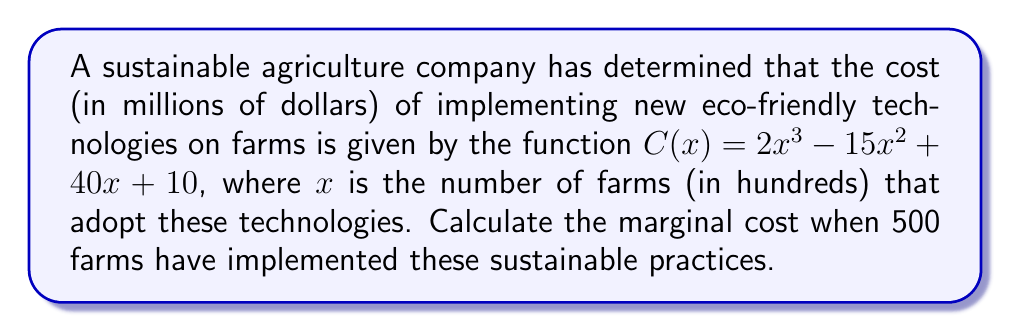Can you solve this math problem? To solve this problem, we need to follow these steps:

1) The marginal cost is given by the derivative of the cost function $C(x)$.

2) Let's find the derivative $C'(x)$:
   $$C'(x) = \frac{d}{dx}(2x^3 - 15x^2 + 40x + 10)$$
   $$C'(x) = 6x^2 - 30x + 40$$

3) We're asked to find the marginal cost when 500 farms have implemented the technologies. In the function, $x$ is in hundreds of farms, so 500 farms is represented by $x = 5$.

4) Now, let's substitute $x = 5$ into our derivative function:
   $$C'(5) = 6(5)^2 - 30(5) + 40$$
   $$C'(5) = 6(25) - 150 + 40$$
   $$C'(5) = 150 - 150 + 40$$
   $$C'(5) = 40$$

5) Therefore, the marginal cost when 500 farms have implemented the sustainable practices is 40 million dollars.
Answer: $40$ million dollars 